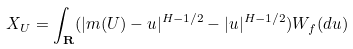Convert formula to latex. <formula><loc_0><loc_0><loc_500><loc_500>X _ { U } = \int _ { \mathbf R } ( | m ( U ) - u | ^ { H - 1 / 2 } - | u | ^ { H - 1 / 2 } ) W _ { f } ( d u )</formula> 